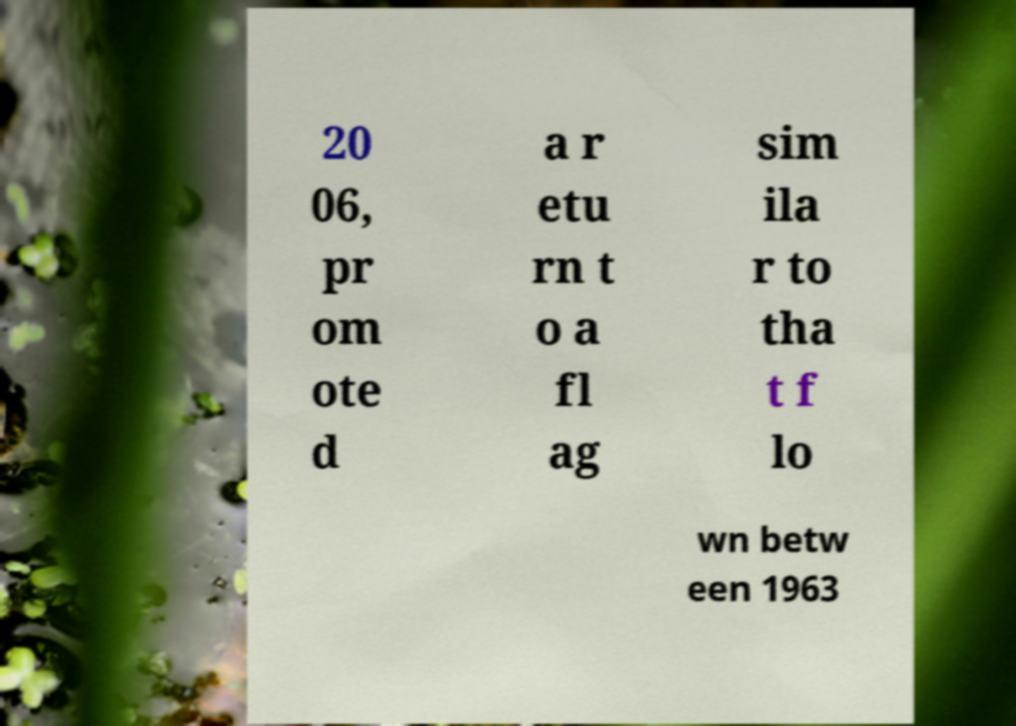Could you extract and type out the text from this image? 20 06, pr om ote d a r etu rn t o a fl ag sim ila r to tha t f lo wn betw een 1963 